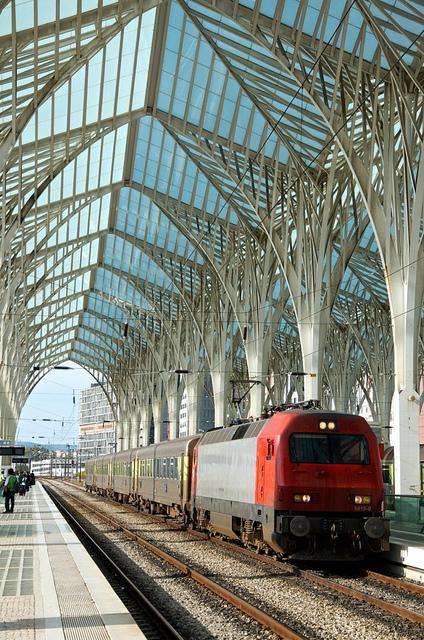How many lights are lit up above the engineers window on the train?
Concise answer only. 2. Is it inside or outside?
Answer briefly. Inside. Where are the pedestrians walking?
Keep it brief. On left side. 